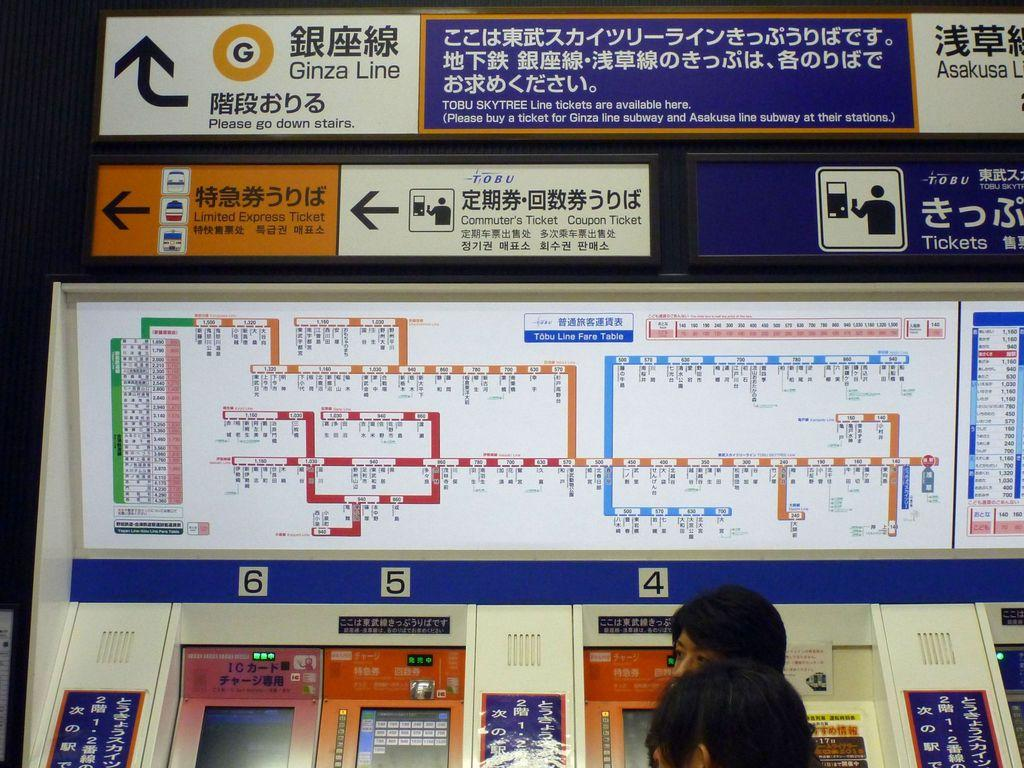What type of objects can be seen in the image? There are electronic machines in the image. Are there any people present in the image? Yes, there are people standing in the image. What can be found on the board in the image? There is text written on a board in the image. What type of wound can be seen on the person's hand in the image? There is no wound visible on any person's hand in the image. What type of chalk is being used to write on the board in the image? There is no chalk visible in the image, and it is not mentioned whether chalk is being used to write on the board. 